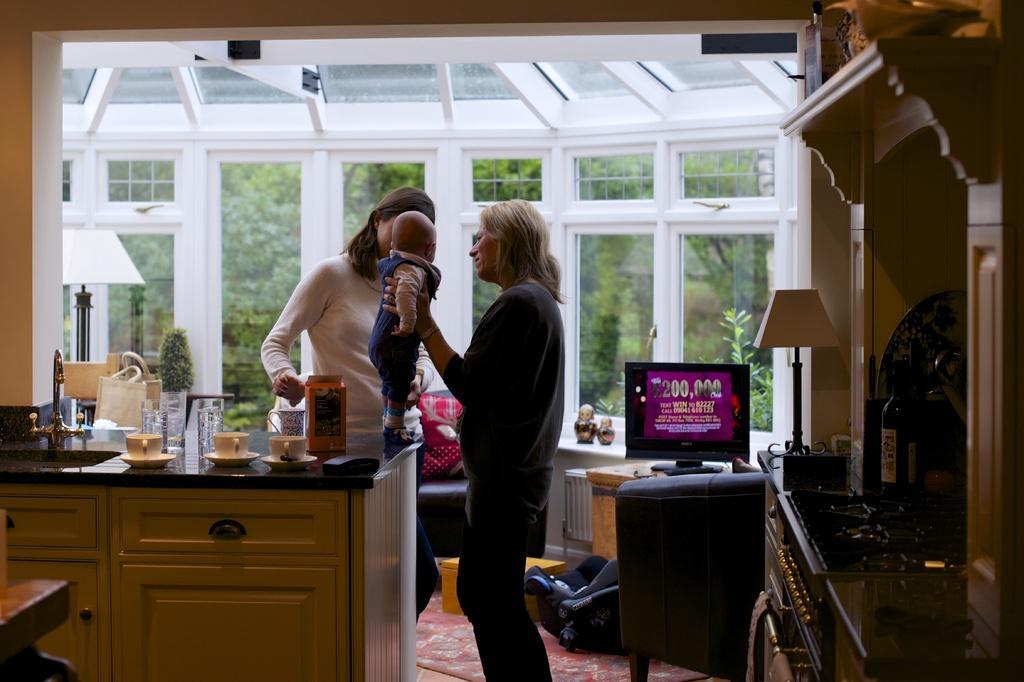Please provide a concise description of this image. In this picture I can see two women are standing among them one woman is holding baby, around there are some things are placed. 